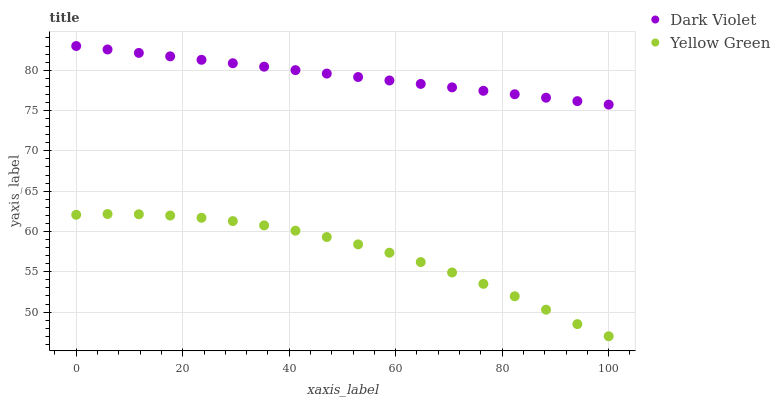Does Yellow Green have the minimum area under the curve?
Answer yes or no. Yes. Does Dark Violet have the maximum area under the curve?
Answer yes or no. Yes. Does Dark Violet have the minimum area under the curve?
Answer yes or no. No. Is Dark Violet the smoothest?
Answer yes or no. Yes. Is Yellow Green the roughest?
Answer yes or no. Yes. Is Dark Violet the roughest?
Answer yes or no. No. Does Yellow Green have the lowest value?
Answer yes or no. Yes. Does Dark Violet have the lowest value?
Answer yes or no. No. Does Dark Violet have the highest value?
Answer yes or no. Yes. Is Yellow Green less than Dark Violet?
Answer yes or no. Yes. Is Dark Violet greater than Yellow Green?
Answer yes or no. Yes. Does Yellow Green intersect Dark Violet?
Answer yes or no. No. 